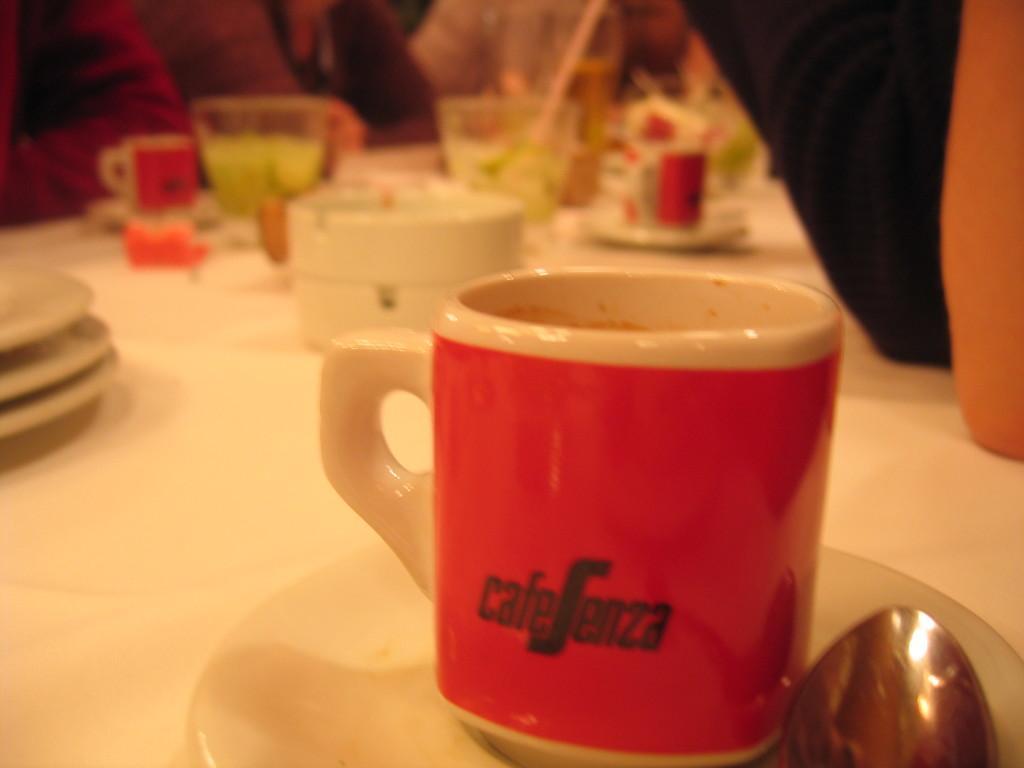Can you describe this image briefly? In this image I can see the white colored table and on the table I can see few plates, few cups, few glasses and few other objects. I can see the blurry background in which I can see few persons. 